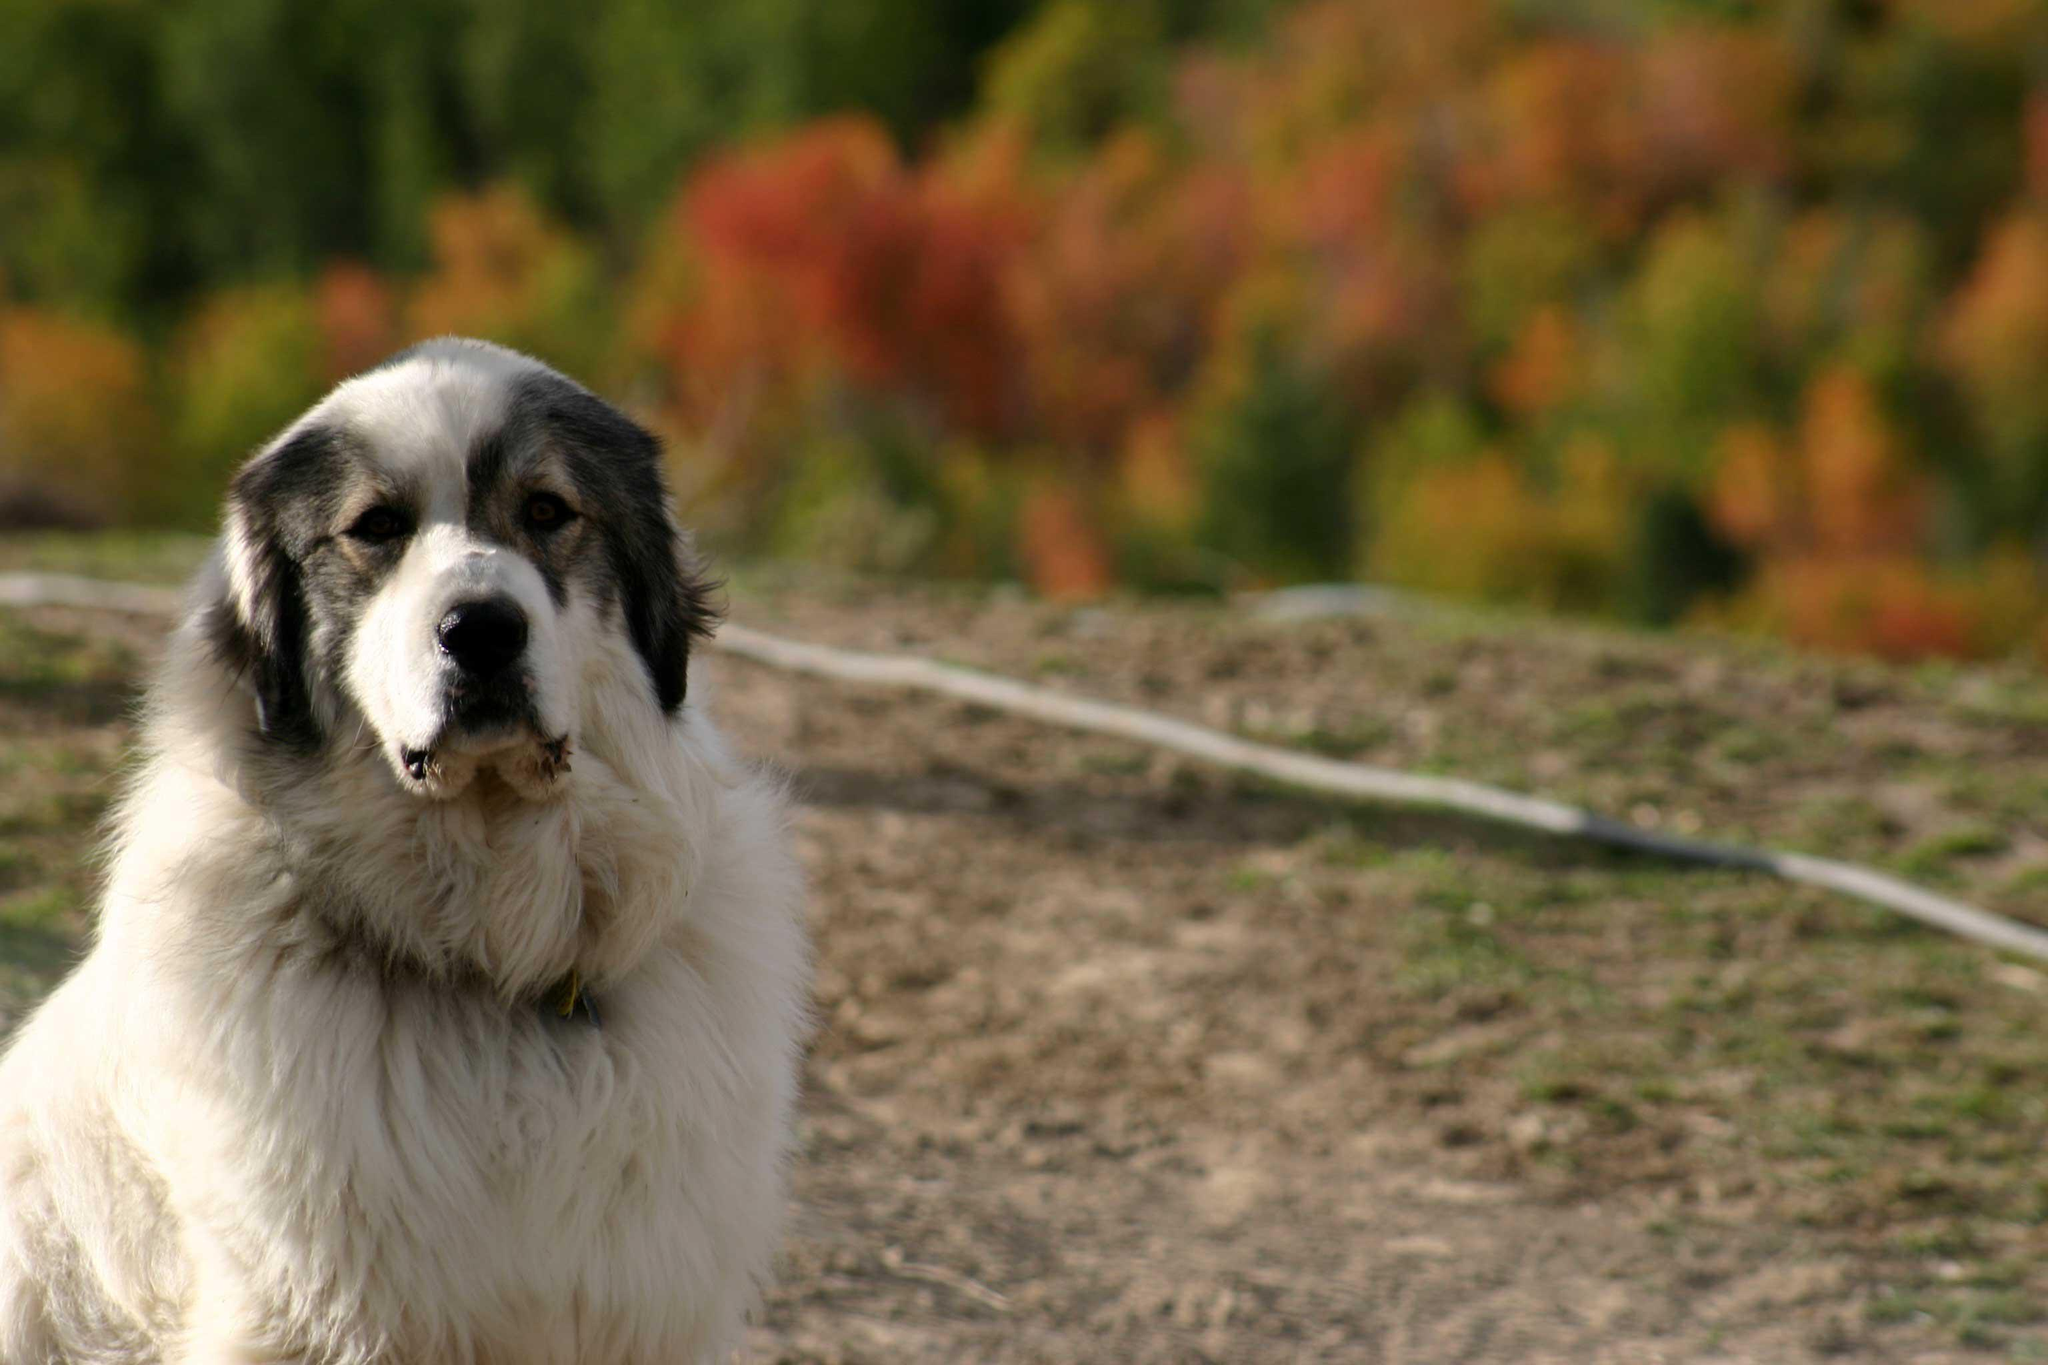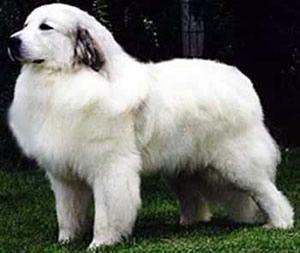The first image is the image on the left, the second image is the image on the right. Considering the images on both sides, is "Right image shows exactly one white dog, which is standing on all fours on grass." valid? Answer yes or no. Yes. The first image is the image on the left, the second image is the image on the right. Given the left and right images, does the statement "The dog in the image on the right is on green grass." hold true? Answer yes or no. Yes. 